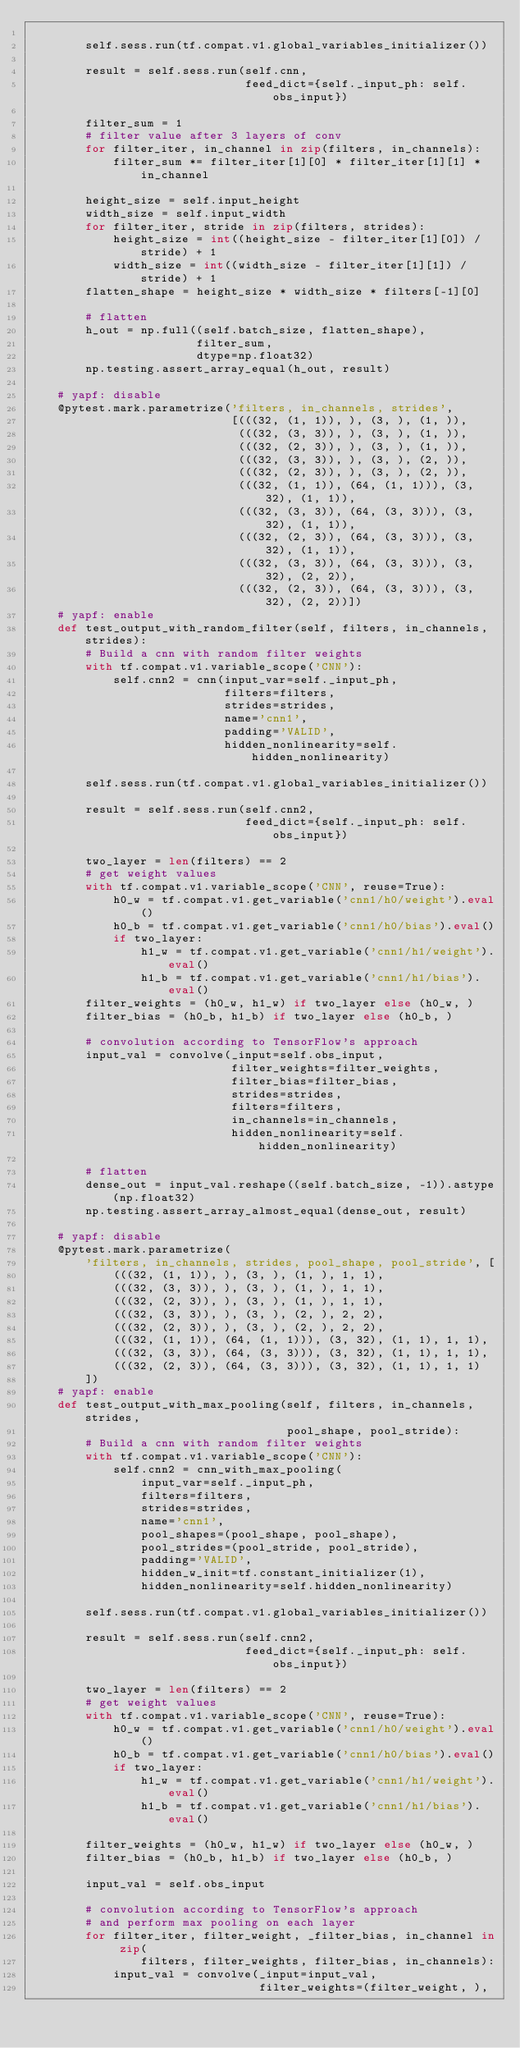<code> <loc_0><loc_0><loc_500><loc_500><_Python_>
        self.sess.run(tf.compat.v1.global_variables_initializer())

        result = self.sess.run(self.cnn,
                               feed_dict={self._input_ph: self.obs_input})

        filter_sum = 1
        # filter value after 3 layers of conv
        for filter_iter, in_channel in zip(filters, in_channels):
            filter_sum *= filter_iter[1][0] * filter_iter[1][1] * in_channel

        height_size = self.input_height
        width_size = self.input_width
        for filter_iter, stride in zip(filters, strides):
            height_size = int((height_size - filter_iter[1][0]) / stride) + 1
            width_size = int((width_size - filter_iter[1][1]) / stride) + 1
        flatten_shape = height_size * width_size * filters[-1][0]

        # flatten
        h_out = np.full((self.batch_size, flatten_shape),
                        filter_sum,
                        dtype=np.float32)
        np.testing.assert_array_equal(h_out, result)

    # yapf: disable
    @pytest.mark.parametrize('filters, in_channels, strides',
                             [(((32, (1, 1)), ), (3, ), (1, )),
                              (((32, (3, 3)), ), (3, ), (1, )),
                              (((32, (2, 3)), ), (3, ), (1, )),
                              (((32, (3, 3)), ), (3, ), (2, )),
                              (((32, (2, 3)), ), (3, ), (2, )),
                              (((32, (1, 1)), (64, (1, 1))), (3, 32), (1, 1)),
                              (((32, (3, 3)), (64, (3, 3))), (3, 32), (1, 1)),
                              (((32, (2, 3)), (64, (3, 3))), (3, 32), (1, 1)),
                              (((32, (3, 3)), (64, (3, 3))), (3, 32), (2, 2)),
                              (((32, (2, 3)), (64, (3, 3))), (3, 32), (2, 2))])
    # yapf: enable
    def test_output_with_random_filter(self, filters, in_channels, strides):
        # Build a cnn with random filter weights
        with tf.compat.v1.variable_scope('CNN'):
            self.cnn2 = cnn(input_var=self._input_ph,
                            filters=filters,
                            strides=strides,
                            name='cnn1',
                            padding='VALID',
                            hidden_nonlinearity=self.hidden_nonlinearity)

        self.sess.run(tf.compat.v1.global_variables_initializer())

        result = self.sess.run(self.cnn2,
                               feed_dict={self._input_ph: self.obs_input})

        two_layer = len(filters) == 2
        # get weight values
        with tf.compat.v1.variable_scope('CNN', reuse=True):
            h0_w = tf.compat.v1.get_variable('cnn1/h0/weight').eval()
            h0_b = tf.compat.v1.get_variable('cnn1/h0/bias').eval()
            if two_layer:
                h1_w = tf.compat.v1.get_variable('cnn1/h1/weight').eval()
                h1_b = tf.compat.v1.get_variable('cnn1/h1/bias').eval()
        filter_weights = (h0_w, h1_w) if two_layer else (h0_w, )
        filter_bias = (h0_b, h1_b) if two_layer else (h0_b, )

        # convolution according to TensorFlow's approach
        input_val = convolve(_input=self.obs_input,
                             filter_weights=filter_weights,
                             filter_bias=filter_bias,
                             strides=strides,
                             filters=filters,
                             in_channels=in_channels,
                             hidden_nonlinearity=self.hidden_nonlinearity)

        # flatten
        dense_out = input_val.reshape((self.batch_size, -1)).astype(np.float32)
        np.testing.assert_array_almost_equal(dense_out, result)

    # yapf: disable
    @pytest.mark.parametrize(
        'filters, in_channels, strides, pool_shape, pool_stride', [
            (((32, (1, 1)), ), (3, ), (1, ), 1, 1),
            (((32, (3, 3)), ), (3, ), (1, ), 1, 1),
            (((32, (2, 3)), ), (3, ), (1, ), 1, 1),
            (((32, (3, 3)), ), (3, ), (2, ), 2, 2),
            (((32, (2, 3)), ), (3, ), (2, ), 2, 2),
            (((32, (1, 1)), (64, (1, 1))), (3, 32), (1, 1), 1, 1),
            (((32, (3, 3)), (64, (3, 3))), (3, 32), (1, 1), 1, 1),
            (((32, (2, 3)), (64, (3, 3))), (3, 32), (1, 1), 1, 1)
        ])
    # yapf: enable
    def test_output_with_max_pooling(self, filters, in_channels, strides,
                                     pool_shape, pool_stride):
        # Build a cnn with random filter weights
        with tf.compat.v1.variable_scope('CNN'):
            self.cnn2 = cnn_with_max_pooling(
                input_var=self._input_ph,
                filters=filters,
                strides=strides,
                name='cnn1',
                pool_shapes=(pool_shape, pool_shape),
                pool_strides=(pool_stride, pool_stride),
                padding='VALID',
                hidden_w_init=tf.constant_initializer(1),
                hidden_nonlinearity=self.hidden_nonlinearity)

        self.sess.run(tf.compat.v1.global_variables_initializer())

        result = self.sess.run(self.cnn2,
                               feed_dict={self._input_ph: self.obs_input})

        two_layer = len(filters) == 2
        # get weight values
        with tf.compat.v1.variable_scope('CNN', reuse=True):
            h0_w = tf.compat.v1.get_variable('cnn1/h0/weight').eval()
            h0_b = tf.compat.v1.get_variable('cnn1/h0/bias').eval()
            if two_layer:
                h1_w = tf.compat.v1.get_variable('cnn1/h1/weight').eval()
                h1_b = tf.compat.v1.get_variable('cnn1/h1/bias').eval()

        filter_weights = (h0_w, h1_w) if two_layer else (h0_w, )
        filter_bias = (h0_b, h1_b) if two_layer else (h0_b, )

        input_val = self.obs_input

        # convolution according to TensorFlow's approach
        # and perform max pooling on each layer
        for filter_iter, filter_weight, _filter_bias, in_channel in zip(
                filters, filter_weights, filter_bias, in_channels):
            input_val = convolve(_input=input_val,
                                 filter_weights=(filter_weight, ),</code> 